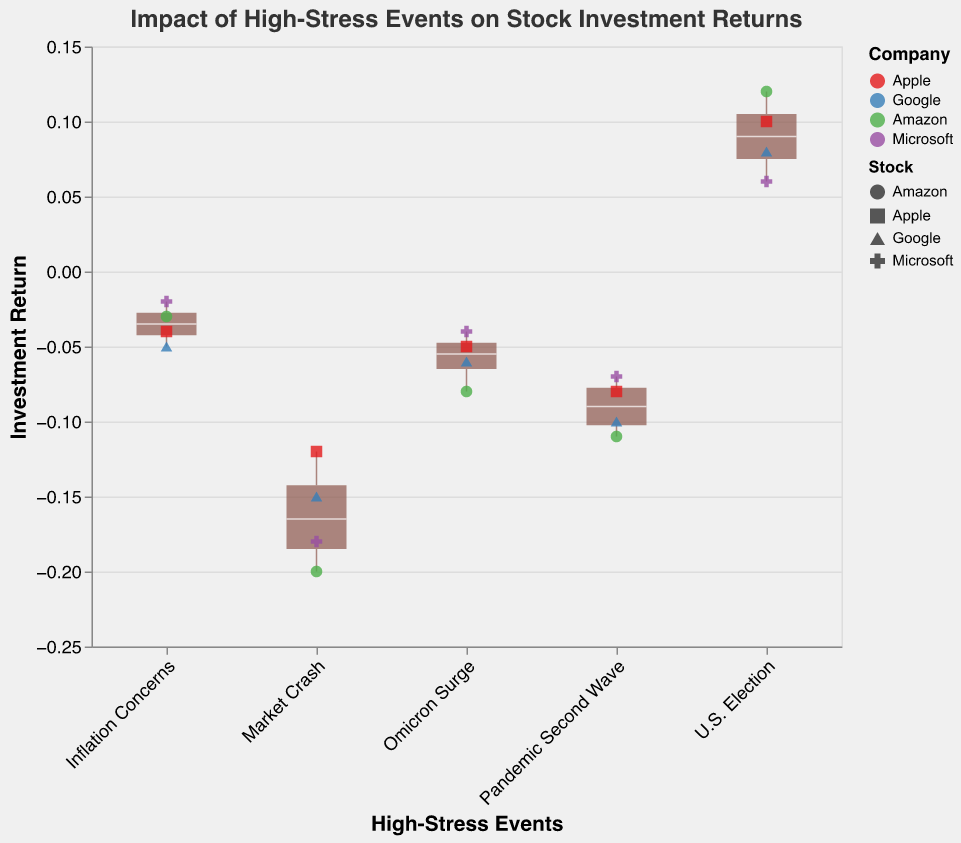What is the title of the figure? The title of the figure is located at the top and describes what the figure is about. It reads "Impact of High-Stress Events on Stock Investment Returns".
Answer: Impact of High-Stress Events on Stock Investment Returns What events are associated with positive investment returns? By examining the different events and their corresponding investment returns (Y-axis values), we see that only the "U.S. Election" event has positive investment returns for all stocks.
Answer: U.S. Election Which company had the lowest investment return during the "Market Crash"? By looking at the scatter points and the Y-axis values for the "Market Crash" event, we see that Amazon has the lowest investment return of -0.20.
Answer: Amazon How do the investment returns for Apple compare between the "Market Crash" and "U.S. Election"? During the "Market Crash", Apple's investment return is -0.12, while during the "U.S. Election", it is 0.10. The return improved by 0.22.
Answer: Improved by 0.22 What is the median investment return during the "Pandemic Second Wave"? In a box plot, the median is the line inside the box. By looking at the "Pandemic Second Wave" event, the median line is at -0.085.
Answer: -0.085 What stock had the smallest variation in returns across all events? The smallest variation in returns can be deduced by observing the scatter points for each stock. Microsoft shows the smallest spread in returns across all events, ranging from -0.18 to 0.06.
Answer: Microsoft Which event has the widest range of investment returns? The range of an event can be found by looking at the maximum and minimum lines in the box plot. The "Market Crash" event has the widest range of -0.20 to -0.12.
Answer: Market Crash During which event did all companies have negative returns but with the least drastic fall? By checking the scatter points in relation to the Y-axis, we determine that the "Inflation Concerns" event had all companies with negative returns but the least drastic falls, ranging from -0.04 to -0.02.
Answer: Inflation Concerns What was Amazon's return during the "Omicron Surge"? By locating the "Omicron Surge" event and finding the scatter point for Amazon, we see that Amazon had an investment return of -0.08.
Answer: -0.08 